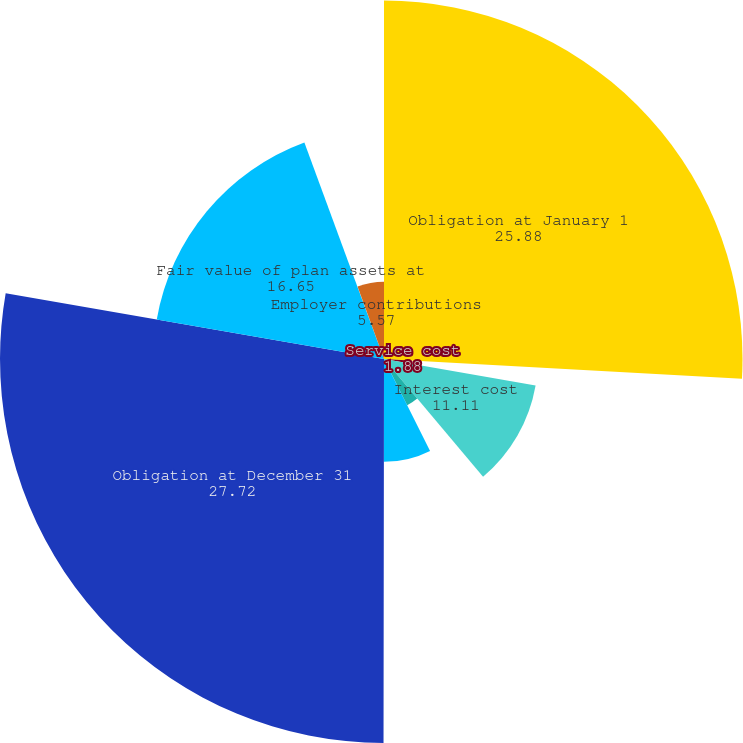<chart> <loc_0><loc_0><loc_500><loc_500><pie_chart><fcel>Obligation at January 1<fcel>Service cost<fcel>Interest cost<fcel>Actuarial (gain) loss<fcel>Benefit payments<fcel>Obligation at December 31<fcel>Fair value of plan assets at<fcel>Actual return on plan assets<fcel>Employer contributions<nl><fcel>25.88%<fcel>1.88%<fcel>11.11%<fcel>3.73%<fcel>7.42%<fcel>27.72%<fcel>16.65%<fcel>0.04%<fcel>5.57%<nl></chart> 